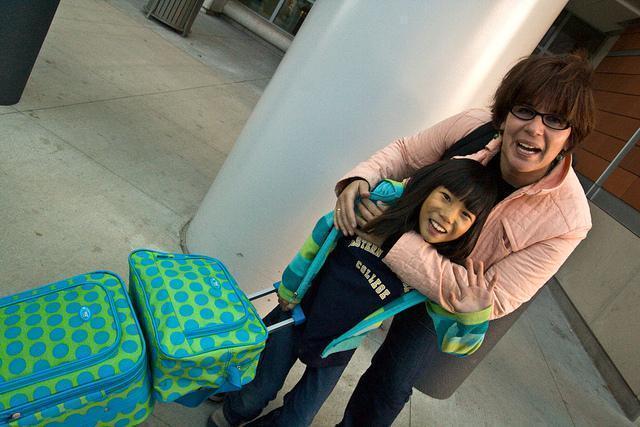Why is the young girl holding luggage?
Make your selection from the four choices given to correctly answer the question.
Options: To sell, to travel, to pack, to purchase. To travel. 